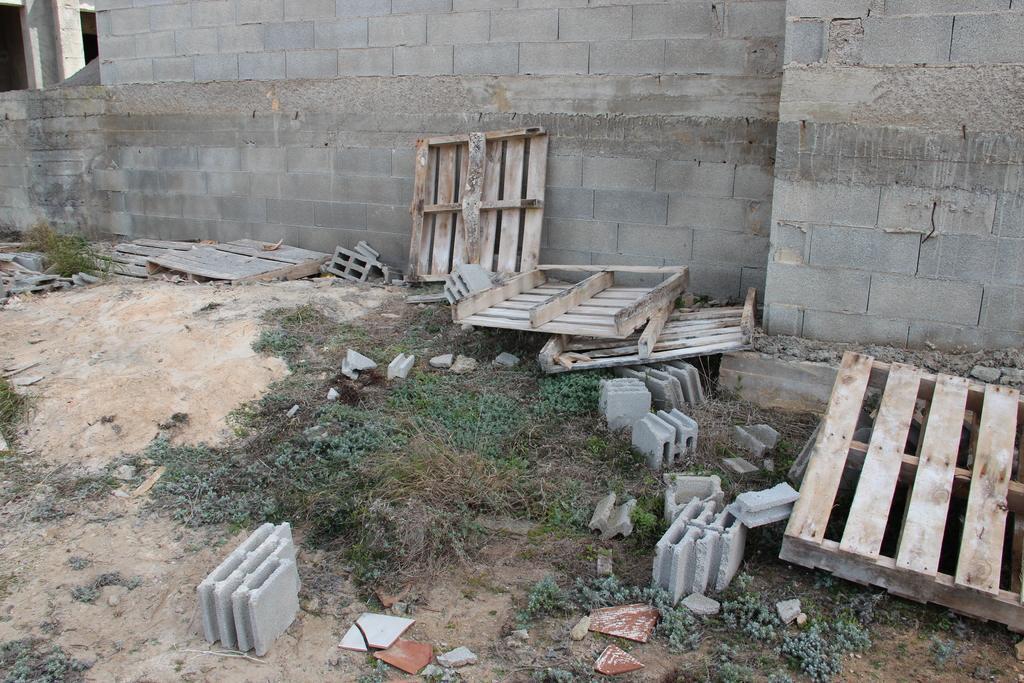Describe this image in one or two sentences. In this image we can see wall with concrete bricks, wooden planks and concrete tiles on the ground. 